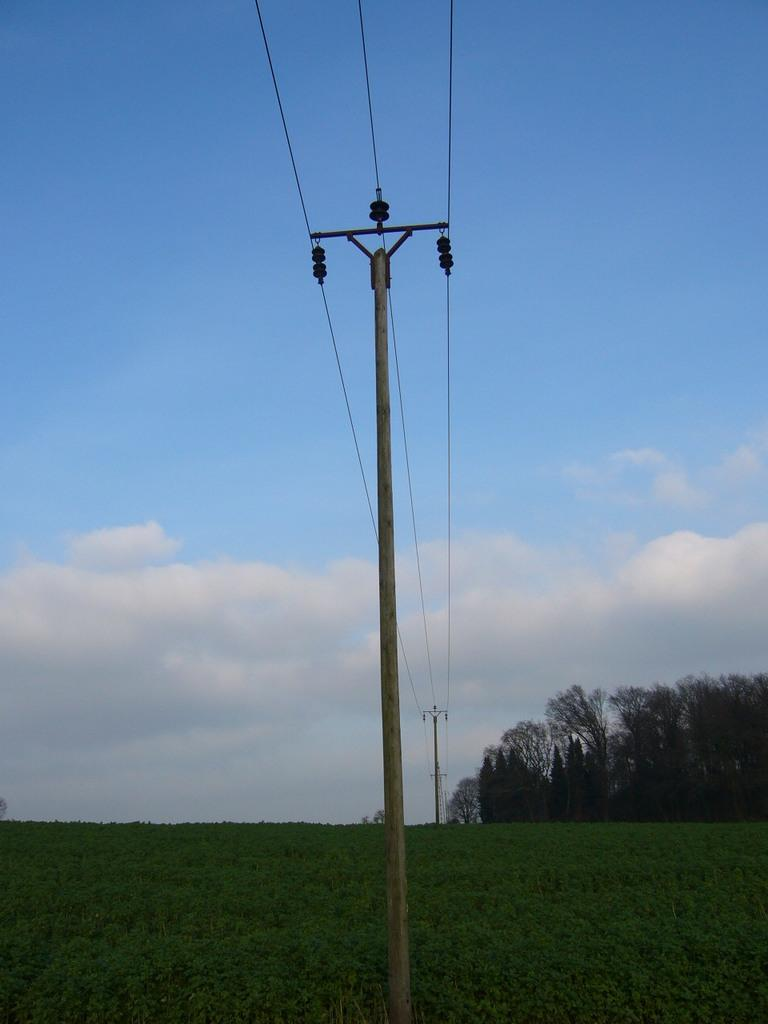What type of structures can be seen in the image? There are current poles in the image. What else is present alongside the current poles? There are wires in the image. What type of natural environment is visible in the image? There is grass and trees in the image. What can be seen in the background of the image? The sky is blue, and there are clouds in the background of the image. Where is the bulb located in the image? There is no bulb present in the image. What type of wheel can be seen in the image? There is no wheel present in the image. 